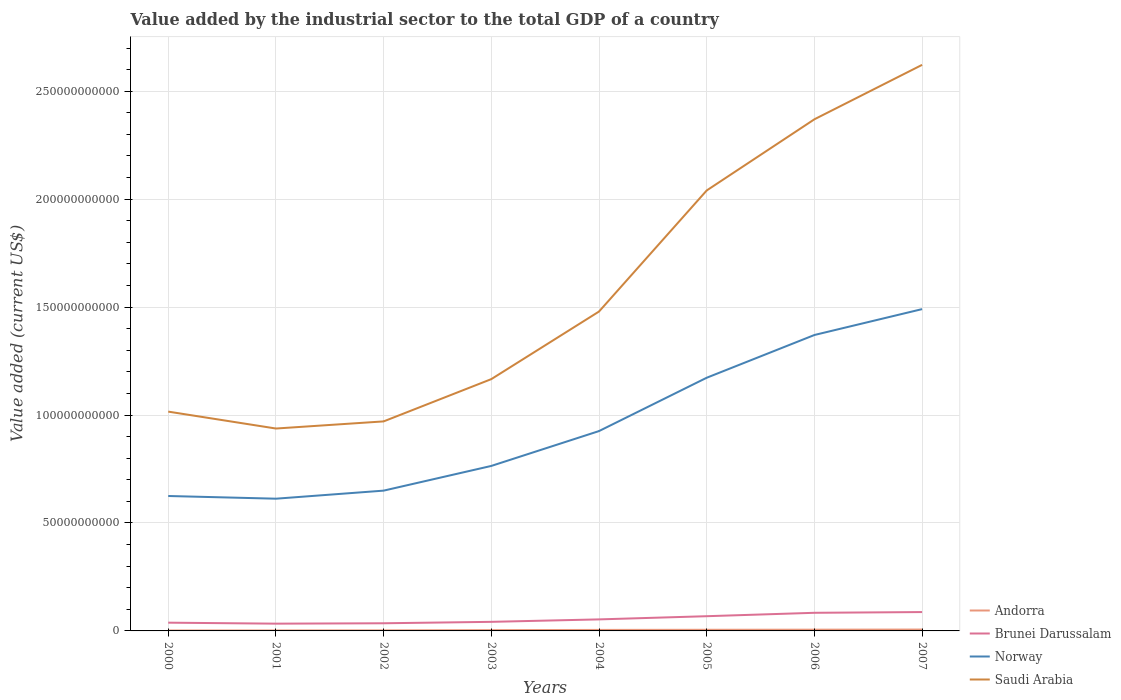How many different coloured lines are there?
Keep it short and to the point. 4. Is the number of lines equal to the number of legend labels?
Your answer should be compact. Yes. Across all years, what is the maximum value added by the industrial sector to the total GDP in Brunei Darussalam?
Your answer should be very brief. 3.36e+09. What is the total value added by the industrial sector to the total GDP in Norway in the graph?
Your response must be concise. -1.20e+1. What is the difference between the highest and the second highest value added by the industrial sector to the total GDP in Saudi Arabia?
Offer a very short reply. 1.68e+11. Is the value added by the industrial sector to the total GDP in Norway strictly greater than the value added by the industrial sector to the total GDP in Brunei Darussalam over the years?
Keep it short and to the point. No. How many lines are there?
Ensure brevity in your answer.  4. What is the difference between two consecutive major ticks on the Y-axis?
Offer a terse response. 5.00e+1. Where does the legend appear in the graph?
Provide a short and direct response. Bottom right. How many legend labels are there?
Ensure brevity in your answer.  4. How are the legend labels stacked?
Your response must be concise. Vertical. What is the title of the graph?
Make the answer very short. Value added by the industrial sector to the total GDP of a country. Does "United Kingdom" appear as one of the legend labels in the graph?
Ensure brevity in your answer.  No. What is the label or title of the X-axis?
Your response must be concise. Years. What is the label or title of the Y-axis?
Offer a terse response. Value added (current US$). What is the Value added (current US$) of Andorra in 2000?
Provide a succinct answer. 2.00e+08. What is the Value added (current US$) of Brunei Darussalam in 2000?
Your response must be concise. 3.82e+09. What is the Value added (current US$) in Norway in 2000?
Your answer should be very brief. 6.25e+1. What is the Value added (current US$) in Saudi Arabia in 2000?
Make the answer very short. 1.02e+11. What is the Value added (current US$) of Andorra in 2001?
Offer a terse response. 2.15e+08. What is the Value added (current US$) in Brunei Darussalam in 2001?
Your answer should be very brief. 3.36e+09. What is the Value added (current US$) of Norway in 2001?
Provide a succinct answer. 6.12e+1. What is the Value added (current US$) in Saudi Arabia in 2001?
Make the answer very short. 9.38e+1. What is the Value added (current US$) of Andorra in 2002?
Offer a very short reply. 2.56e+08. What is the Value added (current US$) of Brunei Darussalam in 2002?
Your answer should be compact. 3.54e+09. What is the Value added (current US$) of Norway in 2002?
Ensure brevity in your answer.  6.50e+1. What is the Value added (current US$) in Saudi Arabia in 2002?
Your answer should be compact. 9.71e+1. What is the Value added (current US$) in Andorra in 2003?
Offer a very short reply. 3.67e+08. What is the Value added (current US$) of Brunei Darussalam in 2003?
Provide a short and direct response. 4.21e+09. What is the Value added (current US$) of Norway in 2003?
Your answer should be compact. 7.64e+1. What is the Value added (current US$) of Saudi Arabia in 2003?
Ensure brevity in your answer.  1.17e+11. What is the Value added (current US$) in Andorra in 2004?
Make the answer very short. 4.62e+08. What is the Value added (current US$) in Brunei Darussalam in 2004?
Provide a short and direct response. 5.34e+09. What is the Value added (current US$) of Norway in 2004?
Give a very brief answer. 9.26e+1. What is the Value added (current US$) in Saudi Arabia in 2004?
Offer a terse response. 1.48e+11. What is the Value added (current US$) of Andorra in 2005?
Ensure brevity in your answer.  5.25e+08. What is the Value added (current US$) in Brunei Darussalam in 2005?
Your response must be concise. 6.82e+09. What is the Value added (current US$) of Norway in 2005?
Keep it short and to the point. 1.17e+11. What is the Value added (current US$) of Saudi Arabia in 2005?
Give a very brief answer. 2.04e+11. What is the Value added (current US$) of Andorra in 2006?
Provide a short and direct response. 5.82e+08. What is the Value added (current US$) of Brunei Darussalam in 2006?
Provide a short and direct response. 8.39e+09. What is the Value added (current US$) in Norway in 2006?
Make the answer very short. 1.37e+11. What is the Value added (current US$) of Saudi Arabia in 2006?
Provide a succinct answer. 2.37e+11. What is the Value added (current US$) of Andorra in 2007?
Offer a terse response. 6.37e+08. What is the Value added (current US$) in Brunei Darussalam in 2007?
Keep it short and to the point. 8.73e+09. What is the Value added (current US$) in Norway in 2007?
Make the answer very short. 1.49e+11. What is the Value added (current US$) in Saudi Arabia in 2007?
Make the answer very short. 2.62e+11. Across all years, what is the maximum Value added (current US$) in Andorra?
Your response must be concise. 6.37e+08. Across all years, what is the maximum Value added (current US$) in Brunei Darussalam?
Your response must be concise. 8.73e+09. Across all years, what is the maximum Value added (current US$) of Norway?
Provide a succinct answer. 1.49e+11. Across all years, what is the maximum Value added (current US$) of Saudi Arabia?
Your response must be concise. 2.62e+11. Across all years, what is the minimum Value added (current US$) of Andorra?
Make the answer very short. 2.00e+08. Across all years, what is the minimum Value added (current US$) of Brunei Darussalam?
Offer a very short reply. 3.36e+09. Across all years, what is the minimum Value added (current US$) in Norway?
Offer a terse response. 6.12e+1. Across all years, what is the minimum Value added (current US$) of Saudi Arabia?
Your answer should be compact. 9.38e+1. What is the total Value added (current US$) of Andorra in the graph?
Ensure brevity in your answer.  3.24e+09. What is the total Value added (current US$) in Brunei Darussalam in the graph?
Offer a very short reply. 4.42e+1. What is the total Value added (current US$) in Norway in the graph?
Offer a terse response. 7.61e+11. What is the total Value added (current US$) of Saudi Arabia in the graph?
Your answer should be very brief. 1.26e+12. What is the difference between the Value added (current US$) of Andorra in 2000 and that in 2001?
Give a very brief answer. -1.55e+07. What is the difference between the Value added (current US$) in Brunei Darussalam in 2000 and that in 2001?
Make the answer very short. 4.58e+08. What is the difference between the Value added (current US$) in Norway in 2000 and that in 2001?
Your answer should be very brief. 1.25e+09. What is the difference between the Value added (current US$) in Saudi Arabia in 2000 and that in 2001?
Your response must be concise. 7.83e+09. What is the difference between the Value added (current US$) in Andorra in 2000 and that in 2002?
Make the answer very short. -5.67e+07. What is the difference between the Value added (current US$) in Brunei Darussalam in 2000 and that in 2002?
Provide a short and direct response. 2.76e+08. What is the difference between the Value added (current US$) in Norway in 2000 and that in 2002?
Provide a succinct answer. -2.49e+09. What is the difference between the Value added (current US$) of Saudi Arabia in 2000 and that in 2002?
Make the answer very short. 4.53e+09. What is the difference between the Value added (current US$) of Andorra in 2000 and that in 2003?
Your response must be concise. -1.68e+08. What is the difference between the Value added (current US$) of Brunei Darussalam in 2000 and that in 2003?
Give a very brief answer. -3.85e+08. What is the difference between the Value added (current US$) in Norway in 2000 and that in 2003?
Make the answer very short. -1.39e+1. What is the difference between the Value added (current US$) of Saudi Arabia in 2000 and that in 2003?
Offer a terse response. -1.51e+1. What is the difference between the Value added (current US$) in Andorra in 2000 and that in 2004?
Keep it short and to the point. -2.62e+08. What is the difference between the Value added (current US$) in Brunei Darussalam in 2000 and that in 2004?
Provide a short and direct response. -1.52e+09. What is the difference between the Value added (current US$) in Norway in 2000 and that in 2004?
Your response must be concise. -3.01e+1. What is the difference between the Value added (current US$) of Saudi Arabia in 2000 and that in 2004?
Provide a short and direct response. -4.64e+1. What is the difference between the Value added (current US$) of Andorra in 2000 and that in 2005?
Your answer should be very brief. -3.25e+08. What is the difference between the Value added (current US$) of Brunei Darussalam in 2000 and that in 2005?
Your answer should be very brief. -3.00e+09. What is the difference between the Value added (current US$) in Norway in 2000 and that in 2005?
Ensure brevity in your answer.  -5.48e+1. What is the difference between the Value added (current US$) of Saudi Arabia in 2000 and that in 2005?
Give a very brief answer. -1.02e+11. What is the difference between the Value added (current US$) of Andorra in 2000 and that in 2006?
Offer a terse response. -3.82e+08. What is the difference between the Value added (current US$) in Brunei Darussalam in 2000 and that in 2006?
Your answer should be compact. -4.57e+09. What is the difference between the Value added (current US$) in Norway in 2000 and that in 2006?
Offer a terse response. -7.46e+1. What is the difference between the Value added (current US$) of Saudi Arabia in 2000 and that in 2006?
Make the answer very short. -1.35e+11. What is the difference between the Value added (current US$) in Andorra in 2000 and that in 2007?
Offer a terse response. -4.37e+08. What is the difference between the Value added (current US$) in Brunei Darussalam in 2000 and that in 2007?
Offer a terse response. -4.91e+09. What is the difference between the Value added (current US$) in Norway in 2000 and that in 2007?
Give a very brief answer. -8.66e+1. What is the difference between the Value added (current US$) of Saudi Arabia in 2000 and that in 2007?
Offer a very short reply. -1.61e+11. What is the difference between the Value added (current US$) of Andorra in 2001 and that in 2002?
Your answer should be compact. -4.12e+07. What is the difference between the Value added (current US$) in Brunei Darussalam in 2001 and that in 2002?
Make the answer very short. -1.82e+08. What is the difference between the Value added (current US$) of Norway in 2001 and that in 2002?
Make the answer very short. -3.73e+09. What is the difference between the Value added (current US$) of Saudi Arabia in 2001 and that in 2002?
Keep it short and to the point. -3.30e+09. What is the difference between the Value added (current US$) of Andorra in 2001 and that in 2003?
Keep it short and to the point. -1.52e+08. What is the difference between the Value added (current US$) of Brunei Darussalam in 2001 and that in 2003?
Give a very brief answer. -8.43e+08. What is the difference between the Value added (current US$) of Norway in 2001 and that in 2003?
Give a very brief answer. -1.52e+1. What is the difference between the Value added (current US$) in Saudi Arabia in 2001 and that in 2003?
Provide a short and direct response. -2.29e+1. What is the difference between the Value added (current US$) in Andorra in 2001 and that in 2004?
Offer a terse response. -2.47e+08. What is the difference between the Value added (current US$) in Brunei Darussalam in 2001 and that in 2004?
Your response must be concise. -1.98e+09. What is the difference between the Value added (current US$) of Norway in 2001 and that in 2004?
Provide a succinct answer. -3.13e+1. What is the difference between the Value added (current US$) in Saudi Arabia in 2001 and that in 2004?
Ensure brevity in your answer.  -5.42e+1. What is the difference between the Value added (current US$) of Andorra in 2001 and that in 2005?
Your response must be concise. -3.09e+08. What is the difference between the Value added (current US$) in Brunei Darussalam in 2001 and that in 2005?
Offer a very short reply. -3.46e+09. What is the difference between the Value added (current US$) in Norway in 2001 and that in 2005?
Offer a terse response. -5.60e+1. What is the difference between the Value added (current US$) in Saudi Arabia in 2001 and that in 2005?
Your answer should be very brief. -1.10e+11. What is the difference between the Value added (current US$) of Andorra in 2001 and that in 2006?
Make the answer very short. -3.67e+08. What is the difference between the Value added (current US$) in Brunei Darussalam in 2001 and that in 2006?
Keep it short and to the point. -5.03e+09. What is the difference between the Value added (current US$) in Norway in 2001 and that in 2006?
Ensure brevity in your answer.  -7.58e+1. What is the difference between the Value added (current US$) in Saudi Arabia in 2001 and that in 2006?
Your answer should be very brief. -1.43e+11. What is the difference between the Value added (current US$) of Andorra in 2001 and that in 2007?
Your answer should be very brief. -4.21e+08. What is the difference between the Value added (current US$) of Brunei Darussalam in 2001 and that in 2007?
Ensure brevity in your answer.  -5.37e+09. What is the difference between the Value added (current US$) in Norway in 2001 and that in 2007?
Make the answer very short. -8.78e+1. What is the difference between the Value added (current US$) of Saudi Arabia in 2001 and that in 2007?
Give a very brief answer. -1.68e+11. What is the difference between the Value added (current US$) in Andorra in 2002 and that in 2003?
Keep it short and to the point. -1.11e+08. What is the difference between the Value added (current US$) in Brunei Darussalam in 2002 and that in 2003?
Provide a short and direct response. -6.62e+08. What is the difference between the Value added (current US$) in Norway in 2002 and that in 2003?
Offer a very short reply. -1.14e+1. What is the difference between the Value added (current US$) of Saudi Arabia in 2002 and that in 2003?
Your response must be concise. -1.96e+1. What is the difference between the Value added (current US$) in Andorra in 2002 and that in 2004?
Provide a succinct answer. -2.06e+08. What is the difference between the Value added (current US$) in Brunei Darussalam in 2002 and that in 2004?
Offer a terse response. -1.80e+09. What is the difference between the Value added (current US$) of Norway in 2002 and that in 2004?
Make the answer very short. -2.76e+1. What is the difference between the Value added (current US$) in Saudi Arabia in 2002 and that in 2004?
Offer a terse response. -5.09e+1. What is the difference between the Value added (current US$) of Andorra in 2002 and that in 2005?
Your answer should be very brief. -2.68e+08. What is the difference between the Value added (current US$) of Brunei Darussalam in 2002 and that in 2005?
Make the answer very short. -3.28e+09. What is the difference between the Value added (current US$) in Norway in 2002 and that in 2005?
Give a very brief answer. -5.23e+1. What is the difference between the Value added (current US$) in Saudi Arabia in 2002 and that in 2005?
Provide a short and direct response. -1.07e+11. What is the difference between the Value added (current US$) of Andorra in 2002 and that in 2006?
Your response must be concise. -3.26e+08. What is the difference between the Value added (current US$) in Brunei Darussalam in 2002 and that in 2006?
Your answer should be compact. -4.85e+09. What is the difference between the Value added (current US$) of Norway in 2002 and that in 2006?
Make the answer very short. -7.21e+1. What is the difference between the Value added (current US$) in Saudi Arabia in 2002 and that in 2006?
Make the answer very short. -1.40e+11. What is the difference between the Value added (current US$) of Andorra in 2002 and that in 2007?
Make the answer very short. -3.80e+08. What is the difference between the Value added (current US$) in Brunei Darussalam in 2002 and that in 2007?
Your answer should be very brief. -5.19e+09. What is the difference between the Value added (current US$) of Norway in 2002 and that in 2007?
Keep it short and to the point. -8.41e+1. What is the difference between the Value added (current US$) in Saudi Arabia in 2002 and that in 2007?
Ensure brevity in your answer.  -1.65e+11. What is the difference between the Value added (current US$) in Andorra in 2003 and that in 2004?
Your answer should be very brief. -9.47e+07. What is the difference between the Value added (current US$) of Brunei Darussalam in 2003 and that in 2004?
Make the answer very short. -1.14e+09. What is the difference between the Value added (current US$) in Norway in 2003 and that in 2004?
Your response must be concise. -1.61e+1. What is the difference between the Value added (current US$) of Saudi Arabia in 2003 and that in 2004?
Your answer should be very brief. -3.13e+1. What is the difference between the Value added (current US$) in Andorra in 2003 and that in 2005?
Your answer should be compact. -1.57e+08. What is the difference between the Value added (current US$) of Brunei Darussalam in 2003 and that in 2005?
Your answer should be very brief. -2.61e+09. What is the difference between the Value added (current US$) of Norway in 2003 and that in 2005?
Offer a very short reply. -4.08e+1. What is the difference between the Value added (current US$) of Saudi Arabia in 2003 and that in 2005?
Offer a terse response. -8.74e+1. What is the difference between the Value added (current US$) in Andorra in 2003 and that in 2006?
Your answer should be compact. -2.15e+08. What is the difference between the Value added (current US$) in Brunei Darussalam in 2003 and that in 2006?
Your answer should be very brief. -4.19e+09. What is the difference between the Value added (current US$) of Norway in 2003 and that in 2006?
Keep it short and to the point. -6.06e+1. What is the difference between the Value added (current US$) in Saudi Arabia in 2003 and that in 2006?
Your response must be concise. -1.20e+11. What is the difference between the Value added (current US$) in Andorra in 2003 and that in 2007?
Ensure brevity in your answer.  -2.69e+08. What is the difference between the Value added (current US$) of Brunei Darussalam in 2003 and that in 2007?
Keep it short and to the point. -4.53e+09. What is the difference between the Value added (current US$) of Norway in 2003 and that in 2007?
Offer a terse response. -7.26e+1. What is the difference between the Value added (current US$) in Saudi Arabia in 2003 and that in 2007?
Make the answer very short. -1.46e+11. What is the difference between the Value added (current US$) in Andorra in 2004 and that in 2005?
Keep it short and to the point. -6.25e+07. What is the difference between the Value added (current US$) of Brunei Darussalam in 2004 and that in 2005?
Offer a terse response. -1.48e+09. What is the difference between the Value added (current US$) of Norway in 2004 and that in 2005?
Provide a succinct answer. -2.47e+1. What is the difference between the Value added (current US$) of Saudi Arabia in 2004 and that in 2005?
Your response must be concise. -5.61e+1. What is the difference between the Value added (current US$) of Andorra in 2004 and that in 2006?
Give a very brief answer. -1.20e+08. What is the difference between the Value added (current US$) in Brunei Darussalam in 2004 and that in 2006?
Give a very brief answer. -3.05e+09. What is the difference between the Value added (current US$) of Norway in 2004 and that in 2006?
Provide a short and direct response. -4.45e+1. What is the difference between the Value added (current US$) in Saudi Arabia in 2004 and that in 2006?
Your answer should be very brief. -8.90e+1. What is the difference between the Value added (current US$) in Andorra in 2004 and that in 2007?
Ensure brevity in your answer.  -1.74e+08. What is the difference between the Value added (current US$) of Brunei Darussalam in 2004 and that in 2007?
Provide a short and direct response. -3.39e+09. What is the difference between the Value added (current US$) of Norway in 2004 and that in 2007?
Your answer should be compact. -5.65e+1. What is the difference between the Value added (current US$) of Saudi Arabia in 2004 and that in 2007?
Provide a succinct answer. -1.14e+11. What is the difference between the Value added (current US$) in Andorra in 2005 and that in 2006?
Offer a very short reply. -5.73e+07. What is the difference between the Value added (current US$) in Brunei Darussalam in 2005 and that in 2006?
Make the answer very short. -1.57e+09. What is the difference between the Value added (current US$) in Norway in 2005 and that in 2006?
Offer a terse response. -1.98e+1. What is the difference between the Value added (current US$) in Saudi Arabia in 2005 and that in 2006?
Keep it short and to the point. -3.30e+1. What is the difference between the Value added (current US$) of Andorra in 2005 and that in 2007?
Offer a terse response. -1.12e+08. What is the difference between the Value added (current US$) in Brunei Darussalam in 2005 and that in 2007?
Provide a short and direct response. -1.91e+09. What is the difference between the Value added (current US$) in Norway in 2005 and that in 2007?
Provide a succinct answer. -3.18e+1. What is the difference between the Value added (current US$) of Saudi Arabia in 2005 and that in 2007?
Your answer should be very brief. -5.82e+1. What is the difference between the Value added (current US$) in Andorra in 2006 and that in 2007?
Provide a short and direct response. -5.46e+07. What is the difference between the Value added (current US$) of Brunei Darussalam in 2006 and that in 2007?
Offer a terse response. -3.39e+08. What is the difference between the Value added (current US$) of Norway in 2006 and that in 2007?
Your answer should be very brief. -1.20e+1. What is the difference between the Value added (current US$) in Saudi Arabia in 2006 and that in 2007?
Provide a succinct answer. -2.52e+1. What is the difference between the Value added (current US$) of Andorra in 2000 and the Value added (current US$) of Brunei Darussalam in 2001?
Your answer should be compact. -3.16e+09. What is the difference between the Value added (current US$) of Andorra in 2000 and the Value added (current US$) of Norway in 2001?
Your response must be concise. -6.10e+1. What is the difference between the Value added (current US$) in Andorra in 2000 and the Value added (current US$) in Saudi Arabia in 2001?
Offer a very short reply. -9.36e+1. What is the difference between the Value added (current US$) in Brunei Darussalam in 2000 and the Value added (current US$) in Norway in 2001?
Offer a terse response. -5.74e+1. What is the difference between the Value added (current US$) in Brunei Darussalam in 2000 and the Value added (current US$) in Saudi Arabia in 2001?
Give a very brief answer. -8.99e+1. What is the difference between the Value added (current US$) in Norway in 2000 and the Value added (current US$) in Saudi Arabia in 2001?
Make the answer very short. -3.13e+1. What is the difference between the Value added (current US$) of Andorra in 2000 and the Value added (current US$) of Brunei Darussalam in 2002?
Your answer should be compact. -3.34e+09. What is the difference between the Value added (current US$) in Andorra in 2000 and the Value added (current US$) in Norway in 2002?
Make the answer very short. -6.48e+1. What is the difference between the Value added (current US$) of Andorra in 2000 and the Value added (current US$) of Saudi Arabia in 2002?
Give a very brief answer. -9.69e+1. What is the difference between the Value added (current US$) of Brunei Darussalam in 2000 and the Value added (current US$) of Norway in 2002?
Your answer should be compact. -6.12e+1. What is the difference between the Value added (current US$) of Brunei Darussalam in 2000 and the Value added (current US$) of Saudi Arabia in 2002?
Offer a very short reply. -9.32e+1. What is the difference between the Value added (current US$) of Norway in 2000 and the Value added (current US$) of Saudi Arabia in 2002?
Keep it short and to the point. -3.46e+1. What is the difference between the Value added (current US$) of Andorra in 2000 and the Value added (current US$) of Brunei Darussalam in 2003?
Make the answer very short. -4.01e+09. What is the difference between the Value added (current US$) of Andorra in 2000 and the Value added (current US$) of Norway in 2003?
Your response must be concise. -7.62e+1. What is the difference between the Value added (current US$) of Andorra in 2000 and the Value added (current US$) of Saudi Arabia in 2003?
Make the answer very short. -1.16e+11. What is the difference between the Value added (current US$) in Brunei Darussalam in 2000 and the Value added (current US$) in Norway in 2003?
Your response must be concise. -7.26e+1. What is the difference between the Value added (current US$) of Brunei Darussalam in 2000 and the Value added (current US$) of Saudi Arabia in 2003?
Make the answer very short. -1.13e+11. What is the difference between the Value added (current US$) of Norway in 2000 and the Value added (current US$) of Saudi Arabia in 2003?
Provide a succinct answer. -5.41e+1. What is the difference between the Value added (current US$) in Andorra in 2000 and the Value added (current US$) in Brunei Darussalam in 2004?
Offer a terse response. -5.14e+09. What is the difference between the Value added (current US$) of Andorra in 2000 and the Value added (current US$) of Norway in 2004?
Your response must be concise. -9.24e+1. What is the difference between the Value added (current US$) of Andorra in 2000 and the Value added (current US$) of Saudi Arabia in 2004?
Make the answer very short. -1.48e+11. What is the difference between the Value added (current US$) of Brunei Darussalam in 2000 and the Value added (current US$) of Norway in 2004?
Offer a very short reply. -8.87e+1. What is the difference between the Value added (current US$) of Brunei Darussalam in 2000 and the Value added (current US$) of Saudi Arabia in 2004?
Provide a succinct answer. -1.44e+11. What is the difference between the Value added (current US$) of Norway in 2000 and the Value added (current US$) of Saudi Arabia in 2004?
Provide a succinct answer. -8.54e+1. What is the difference between the Value added (current US$) of Andorra in 2000 and the Value added (current US$) of Brunei Darussalam in 2005?
Make the answer very short. -6.62e+09. What is the difference between the Value added (current US$) of Andorra in 2000 and the Value added (current US$) of Norway in 2005?
Make the answer very short. -1.17e+11. What is the difference between the Value added (current US$) in Andorra in 2000 and the Value added (current US$) in Saudi Arabia in 2005?
Your answer should be compact. -2.04e+11. What is the difference between the Value added (current US$) of Brunei Darussalam in 2000 and the Value added (current US$) of Norway in 2005?
Provide a short and direct response. -1.13e+11. What is the difference between the Value added (current US$) in Brunei Darussalam in 2000 and the Value added (current US$) in Saudi Arabia in 2005?
Your answer should be very brief. -2.00e+11. What is the difference between the Value added (current US$) in Norway in 2000 and the Value added (current US$) in Saudi Arabia in 2005?
Offer a terse response. -1.42e+11. What is the difference between the Value added (current US$) of Andorra in 2000 and the Value added (current US$) of Brunei Darussalam in 2006?
Provide a short and direct response. -8.19e+09. What is the difference between the Value added (current US$) of Andorra in 2000 and the Value added (current US$) of Norway in 2006?
Give a very brief answer. -1.37e+11. What is the difference between the Value added (current US$) of Andorra in 2000 and the Value added (current US$) of Saudi Arabia in 2006?
Your answer should be compact. -2.37e+11. What is the difference between the Value added (current US$) of Brunei Darussalam in 2000 and the Value added (current US$) of Norway in 2006?
Your answer should be compact. -1.33e+11. What is the difference between the Value added (current US$) in Brunei Darussalam in 2000 and the Value added (current US$) in Saudi Arabia in 2006?
Give a very brief answer. -2.33e+11. What is the difference between the Value added (current US$) of Norway in 2000 and the Value added (current US$) of Saudi Arabia in 2006?
Provide a short and direct response. -1.74e+11. What is the difference between the Value added (current US$) in Andorra in 2000 and the Value added (current US$) in Brunei Darussalam in 2007?
Offer a very short reply. -8.53e+09. What is the difference between the Value added (current US$) of Andorra in 2000 and the Value added (current US$) of Norway in 2007?
Ensure brevity in your answer.  -1.49e+11. What is the difference between the Value added (current US$) of Andorra in 2000 and the Value added (current US$) of Saudi Arabia in 2007?
Make the answer very short. -2.62e+11. What is the difference between the Value added (current US$) of Brunei Darussalam in 2000 and the Value added (current US$) of Norway in 2007?
Your answer should be very brief. -1.45e+11. What is the difference between the Value added (current US$) in Brunei Darussalam in 2000 and the Value added (current US$) in Saudi Arabia in 2007?
Provide a short and direct response. -2.58e+11. What is the difference between the Value added (current US$) of Norway in 2000 and the Value added (current US$) of Saudi Arabia in 2007?
Provide a succinct answer. -2.00e+11. What is the difference between the Value added (current US$) in Andorra in 2001 and the Value added (current US$) in Brunei Darussalam in 2002?
Ensure brevity in your answer.  -3.33e+09. What is the difference between the Value added (current US$) of Andorra in 2001 and the Value added (current US$) of Norway in 2002?
Your answer should be very brief. -6.48e+1. What is the difference between the Value added (current US$) in Andorra in 2001 and the Value added (current US$) in Saudi Arabia in 2002?
Your answer should be compact. -9.68e+1. What is the difference between the Value added (current US$) of Brunei Darussalam in 2001 and the Value added (current US$) of Norway in 2002?
Offer a terse response. -6.16e+1. What is the difference between the Value added (current US$) in Brunei Darussalam in 2001 and the Value added (current US$) in Saudi Arabia in 2002?
Make the answer very short. -9.37e+1. What is the difference between the Value added (current US$) of Norway in 2001 and the Value added (current US$) of Saudi Arabia in 2002?
Provide a short and direct response. -3.58e+1. What is the difference between the Value added (current US$) of Andorra in 2001 and the Value added (current US$) of Brunei Darussalam in 2003?
Offer a terse response. -3.99e+09. What is the difference between the Value added (current US$) of Andorra in 2001 and the Value added (current US$) of Norway in 2003?
Ensure brevity in your answer.  -7.62e+1. What is the difference between the Value added (current US$) of Andorra in 2001 and the Value added (current US$) of Saudi Arabia in 2003?
Offer a very short reply. -1.16e+11. What is the difference between the Value added (current US$) of Brunei Darussalam in 2001 and the Value added (current US$) of Norway in 2003?
Your answer should be compact. -7.31e+1. What is the difference between the Value added (current US$) of Brunei Darussalam in 2001 and the Value added (current US$) of Saudi Arabia in 2003?
Provide a succinct answer. -1.13e+11. What is the difference between the Value added (current US$) in Norway in 2001 and the Value added (current US$) in Saudi Arabia in 2003?
Provide a succinct answer. -5.54e+1. What is the difference between the Value added (current US$) in Andorra in 2001 and the Value added (current US$) in Brunei Darussalam in 2004?
Provide a succinct answer. -5.13e+09. What is the difference between the Value added (current US$) of Andorra in 2001 and the Value added (current US$) of Norway in 2004?
Offer a very short reply. -9.24e+1. What is the difference between the Value added (current US$) of Andorra in 2001 and the Value added (current US$) of Saudi Arabia in 2004?
Offer a terse response. -1.48e+11. What is the difference between the Value added (current US$) of Brunei Darussalam in 2001 and the Value added (current US$) of Norway in 2004?
Give a very brief answer. -8.92e+1. What is the difference between the Value added (current US$) in Brunei Darussalam in 2001 and the Value added (current US$) in Saudi Arabia in 2004?
Make the answer very short. -1.45e+11. What is the difference between the Value added (current US$) in Norway in 2001 and the Value added (current US$) in Saudi Arabia in 2004?
Provide a short and direct response. -8.67e+1. What is the difference between the Value added (current US$) in Andorra in 2001 and the Value added (current US$) in Brunei Darussalam in 2005?
Give a very brief answer. -6.61e+09. What is the difference between the Value added (current US$) in Andorra in 2001 and the Value added (current US$) in Norway in 2005?
Provide a succinct answer. -1.17e+11. What is the difference between the Value added (current US$) of Andorra in 2001 and the Value added (current US$) of Saudi Arabia in 2005?
Your response must be concise. -2.04e+11. What is the difference between the Value added (current US$) in Brunei Darussalam in 2001 and the Value added (current US$) in Norway in 2005?
Your response must be concise. -1.14e+11. What is the difference between the Value added (current US$) in Brunei Darussalam in 2001 and the Value added (current US$) in Saudi Arabia in 2005?
Your answer should be very brief. -2.01e+11. What is the difference between the Value added (current US$) of Norway in 2001 and the Value added (current US$) of Saudi Arabia in 2005?
Your response must be concise. -1.43e+11. What is the difference between the Value added (current US$) in Andorra in 2001 and the Value added (current US$) in Brunei Darussalam in 2006?
Offer a terse response. -8.18e+09. What is the difference between the Value added (current US$) of Andorra in 2001 and the Value added (current US$) of Norway in 2006?
Your response must be concise. -1.37e+11. What is the difference between the Value added (current US$) in Andorra in 2001 and the Value added (current US$) in Saudi Arabia in 2006?
Keep it short and to the point. -2.37e+11. What is the difference between the Value added (current US$) of Brunei Darussalam in 2001 and the Value added (current US$) of Norway in 2006?
Make the answer very short. -1.34e+11. What is the difference between the Value added (current US$) of Brunei Darussalam in 2001 and the Value added (current US$) of Saudi Arabia in 2006?
Provide a short and direct response. -2.34e+11. What is the difference between the Value added (current US$) of Norway in 2001 and the Value added (current US$) of Saudi Arabia in 2006?
Ensure brevity in your answer.  -1.76e+11. What is the difference between the Value added (current US$) of Andorra in 2001 and the Value added (current US$) of Brunei Darussalam in 2007?
Keep it short and to the point. -8.52e+09. What is the difference between the Value added (current US$) of Andorra in 2001 and the Value added (current US$) of Norway in 2007?
Ensure brevity in your answer.  -1.49e+11. What is the difference between the Value added (current US$) of Andorra in 2001 and the Value added (current US$) of Saudi Arabia in 2007?
Provide a short and direct response. -2.62e+11. What is the difference between the Value added (current US$) in Brunei Darussalam in 2001 and the Value added (current US$) in Norway in 2007?
Your answer should be very brief. -1.46e+11. What is the difference between the Value added (current US$) in Brunei Darussalam in 2001 and the Value added (current US$) in Saudi Arabia in 2007?
Offer a very short reply. -2.59e+11. What is the difference between the Value added (current US$) of Norway in 2001 and the Value added (current US$) of Saudi Arabia in 2007?
Offer a very short reply. -2.01e+11. What is the difference between the Value added (current US$) of Andorra in 2002 and the Value added (current US$) of Brunei Darussalam in 2003?
Offer a terse response. -3.95e+09. What is the difference between the Value added (current US$) of Andorra in 2002 and the Value added (current US$) of Norway in 2003?
Make the answer very short. -7.62e+1. What is the difference between the Value added (current US$) of Andorra in 2002 and the Value added (current US$) of Saudi Arabia in 2003?
Provide a succinct answer. -1.16e+11. What is the difference between the Value added (current US$) of Brunei Darussalam in 2002 and the Value added (current US$) of Norway in 2003?
Offer a very short reply. -7.29e+1. What is the difference between the Value added (current US$) of Brunei Darussalam in 2002 and the Value added (current US$) of Saudi Arabia in 2003?
Make the answer very short. -1.13e+11. What is the difference between the Value added (current US$) in Norway in 2002 and the Value added (current US$) in Saudi Arabia in 2003?
Keep it short and to the point. -5.17e+1. What is the difference between the Value added (current US$) in Andorra in 2002 and the Value added (current US$) in Brunei Darussalam in 2004?
Your answer should be very brief. -5.09e+09. What is the difference between the Value added (current US$) of Andorra in 2002 and the Value added (current US$) of Norway in 2004?
Provide a short and direct response. -9.23e+1. What is the difference between the Value added (current US$) in Andorra in 2002 and the Value added (current US$) in Saudi Arabia in 2004?
Give a very brief answer. -1.48e+11. What is the difference between the Value added (current US$) of Brunei Darussalam in 2002 and the Value added (current US$) of Norway in 2004?
Provide a succinct answer. -8.90e+1. What is the difference between the Value added (current US$) in Brunei Darussalam in 2002 and the Value added (current US$) in Saudi Arabia in 2004?
Make the answer very short. -1.44e+11. What is the difference between the Value added (current US$) of Norway in 2002 and the Value added (current US$) of Saudi Arabia in 2004?
Make the answer very short. -8.30e+1. What is the difference between the Value added (current US$) in Andorra in 2002 and the Value added (current US$) in Brunei Darussalam in 2005?
Offer a terse response. -6.56e+09. What is the difference between the Value added (current US$) of Andorra in 2002 and the Value added (current US$) of Norway in 2005?
Your response must be concise. -1.17e+11. What is the difference between the Value added (current US$) of Andorra in 2002 and the Value added (current US$) of Saudi Arabia in 2005?
Your answer should be very brief. -2.04e+11. What is the difference between the Value added (current US$) in Brunei Darussalam in 2002 and the Value added (current US$) in Norway in 2005?
Ensure brevity in your answer.  -1.14e+11. What is the difference between the Value added (current US$) in Brunei Darussalam in 2002 and the Value added (current US$) in Saudi Arabia in 2005?
Your response must be concise. -2.00e+11. What is the difference between the Value added (current US$) of Norway in 2002 and the Value added (current US$) of Saudi Arabia in 2005?
Make the answer very short. -1.39e+11. What is the difference between the Value added (current US$) of Andorra in 2002 and the Value added (current US$) of Brunei Darussalam in 2006?
Ensure brevity in your answer.  -8.14e+09. What is the difference between the Value added (current US$) of Andorra in 2002 and the Value added (current US$) of Norway in 2006?
Provide a succinct answer. -1.37e+11. What is the difference between the Value added (current US$) in Andorra in 2002 and the Value added (current US$) in Saudi Arabia in 2006?
Provide a short and direct response. -2.37e+11. What is the difference between the Value added (current US$) of Brunei Darussalam in 2002 and the Value added (current US$) of Norway in 2006?
Make the answer very short. -1.34e+11. What is the difference between the Value added (current US$) of Brunei Darussalam in 2002 and the Value added (current US$) of Saudi Arabia in 2006?
Provide a succinct answer. -2.33e+11. What is the difference between the Value added (current US$) of Norway in 2002 and the Value added (current US$) of Saudi Arabia in 2006?
Give a very brief answer. -1.72e+11. What is the difference between the Value added (current US$) in Andorra in 2002 and the Value added (current US$) in Brunei Darussalam in 2007?
Make the answer very short. -8.48e+09. What is the difference between the Value added (current US$) in Andorra in 2002 and the Value added (current US$) in Norway in 2007?
Your response must be concise. -1.49e+11. What is the difference between the Value added (current US$) of Andorra in 2002 and the Value added (current US$) of Saudi Arabia in 2007?
Provide a short and direct response. -2.62e+11. What is the difference between the Value added (current US$) in Brunei Darussalam in 2002 and the Value added (current US$) in Norway in 2007?
Keep it short and to the point. -1.46e+11. What is the difference between the Value added (current US$) of Brunei Darussalam in 2002 and the Value added (current US$) of Saudi Arabia in 2007?
Your answer should be compact. -2.59e+11. What is the difference between the Value added (current US$) of Norway in 2002 and the Value added (current US$) of Saudi Arabia in 2007?
Make the answer very short. -1.97e+11. What is the difference between the Value added (current US$) in Andorra in 2003 and the Value added (current US$) in Brunei Darussalam in 2004?
Offer a terse response. -4.97e+09. What is the difference between the Value added (current US$) in Andorra in 2003 and the Value added (current US$) in Norway in 2004?
Ensure brevity in your answer.  -9.22e+1. What is the difference between the Value added (current US$) of Andorra in 2003 and the Value added (current US$) of Saudi Arabia in 2004?
Your answer should be very brief. -1.48e+11. What is the difference between the Value added (current US$) of Brunei Darussalam in 2003 and the Value added (current US$) of Norway in 2004?
Offer a very short reply. -8.84e+1. What is the difference between the Value added (current US$) in Brunei Darussalam in 2003 and the Value added (current US$) in Saudi Arabia in 2004?
Make the answer very short. -1.44e+11. What is the difference between the Value added (current US$) of Norway in 2003 and the Value added (current US$) of Saudi Arabia in 2004?
Keep it short and to the point. -7.15e+1. What is the difference between the Value added (current US$) of Andorra in 2003 and the Value added (current US$) of Brunei Darussalam in 2005?
Your response must be concise. -6.45e+09. What is the difference between the Value added (current US$) in Andorra in 2003 and the Value added (current US$) in Norway in 2005?
Ensure brevity in your answer.  -1.17e+11. What is the difference between the Value added (current US$) in Andorra in 2003 and the Value added (current US$) in Saudi Arabia in 2005?
Offer a very short reply. -2.04e+11. What is the difference between the Value added (current US$) of Brunei Darussalam in 2003 and the Value added (current US$) of Norway in 2005?
Ensure brevity in your answer.  -1.13e+11. What is the difference between the Value added (current US$) of Brunei Darussalam in 2003 and the Value added (current US$) of Saudi Arabia in 2005?
Give a very brief answer. -2.00e+11. What is the difference between the Value added (current US$) in Norway in 2003 and the Value added (current US$) in Saudi Arabia in 2005?
Make the answer very short. -1.28e+11. What is the difference between the Value added (current US$) of Andorra in 2003 and the Value added (current US$) of Brunei Darussalam in 2006?
Provide a short and direct response. -8.03e+09. What is the difference between the Value added (current US$) of Andorra in 2003 and the Value added (current US$) of Norway in 2006?
Give a very brief answer. -1.37e+11. What is the difference between the Value added (current US$) of Andorra in 2003 and the Value added (current US$) of Saudi Arabia in 2006?
Give a very brief answer. -2.37e+11. What is the difference between the Value added (current US$) in Brunei Darussalam in 2003 and the Value added (current US$) in Norway in 2006?
Make the answer very short. -1.33e+11. What is the difference between the Value added (current US$) of Brunei Darussalam in 2003 and the Value added (current US$) of Saudi Arabia in 2006?
Give a very brief answer. -2.33e+11. What is the difference between the Value added (current US$) in Norway in 2003 and the Value added (current US$) in Saudi Arabia in 2006?
Your response must be concise. -1.61e+11. What is the difference between the Value added (current US$) of Andorra in 2003 and the Value added (current US$) of Brunei Darussalam in 2007?
Make the answer very short. -8.37e+09. What is the difference between the Value added (current US$) in Andorra in 2003 and the Value added (current US$) in Norway in 2007?
Provide a succinct answer. -1.49e+11. What is the difference between the Value added (current US$) of Andorra in 2003 and the Value added (current US$) of Saudi Arabia in 2007?
Give a very brief answer. -2.62e+11. What is the difference between the Value added (current US$) of Brunei Darussalam in 2003 and the Value added (current US$) of Norway in 2007?
Offer a very short reply. -1.45e+11. What is the difference between the Value added (current US$) of Brunei Darussalam in 2003 and the Value added (current US$) of Saudi Arabia in 2007?
Give a very brief answer. -2.58e+11. What is the difference between the Value added (current US$) in Norway in 2003 and the Value added (current US$) in Saudi Arabia in 2007?
Make the answer very short. -1.86e+11. What is the difference between the Value added (current US$) in Andorra in 2004 and the Value added (current US$) in Brunei Darussalam in 2005?
Give a very brief answer. -6.36e+09. What is the difference between the Value added (current US$) of Andorra in 2004 and the Value added (current US$) of Norway in 2005?
Offer a very short reply. -1.17e+11. What is the difference between the Value added (current US$) in Andorra in 2004 and the Value added (current US$) in Saudi Arabia in 2005?
Offer a very short reply. -2.04e+11. What is the difference between the Value added (current US$) in Brunei Darussalam in 2004 and the Value added (current US$) in Norway in 2005?
Ensure brevity in your answer.  -1.12e+11. What is the difference between the Value added (current US$) of Brunei Darussalam in 2004 and the Value added (current US$) of Saudi Arabia in 2005?
Provide a short and direct response. -1.99e+11. What is the difference between the Value added (current US$) in Norway in 2004 and the Value added (current US$) in Saudi Arabia in 2005?
Give a very brief answer. -1.11e+11. What is the difference between the Value added (current US$) of Andorra in 2004 and the Value added (current US$) of Brunei Darussalam in 2006?
Give a very brief answer. -7.93e+09. What is the difference between the Value added (current US$) in Andorra in 2004 and the Value added (current US$) in Norway in 2006?
Offer a very short reply. -1.37e+11. What is the difference between the Value added (current US$) of Andorra in 2004 and the Value added (current US$) of Saudi Arabia in 2006?
Ensure brevity in your answer.  -2.37e+11. What is the difference between the Value added (current US$) in Brunei Darussalam in 2004 and the Value added (current US$) in Norway in 2006?
Ensure brevity in your answer.  -1.32e+11. What is the difference between the Value added (current US$) in Brunei Darussalam in 2004 and the Value added (current US$) in Saudi Arabia in 2006?
Your answer should be very brief. -2.32e+11. What is the difference between the Value added (current US$) in Norway in 2004 and the Value added (current US$) in Saudi Arabia in 2006?
Your response must be concise. -1.44e+11. What is the difference between the Value added (current US$) of Andorra in 2004 and the Value added (current US$) of Brunei Darussalam in 2007?
Keep it short and to the point. -8.27e+09. What is the difference between the Value added (current US$) in Andorra in 2004 and the Value added (current US$) in Norway in 2007?
Provide a succinct answer. -1.49e+11. What is the difference between the Value added (current US$) in Andorra in 2004 and the Value added (current US$) in Saudi Arabia in 2007?
Provide a succinct answer. -2.62e+11. What is the difference between the Value added (current US$) in Brunei Darussalam in 2004 and the Value added (current US$) in Norway in 2007?
Your answer should be compact. -1.44e+11. What is the difference between the Value added (current US$) in Brunei Darussalam in 2004 and the Value added (current US$) in Saudi Arabia in 2007?
Make the answer very short. -2.57e+11. What is the difference between the Value added (current US$) of Norway in 2004 and the Value added (current US$) of Saudi Arabia in 2007?
Keep it short and to the point. -1.70e+11. What is the difference between the Value added (current US$) of Andorra in 2005 and the Value added (current US$) of Brunei Darussalam in 2006?
Make the answer very short. -7.87e+09. What is the difference between the Value added (current US$) of Andorra in 2005 and the Value added (current US$) of Norway in 2006?
Offer a very short reply. -1.37e+11. What is the difference between the Value added (current US$) in Andorra in 2005 and the Value added (current US$) in Saudi Arabia in 2006?
Provide a short and direct response. -2.36e+11. What is the difference between the Value added (current US$) in Brunei Darussalam in 2005 and the Value added (current US$) in Norway in 2006?
Provide a succinct answer. -1.30e+11. What is the difference between the Value added (current US$) of Brunei Darussalam in 2005 and the Value added (current US$) of Saudi Arabia in 2006?
Ensure brevity in your answer.  -2.30e+11. What is the difference between the Value added (current US$) in Norway in 2005 and the Value added (current US$) in Saudi Arabia in 2006?
Keep it short and to the point. -1.20e+11. What is the difference between the Value added (current US$) of Andorra in 2005 and the Value added (current US$) of Brunei Darussalam in 2007?
Make the answer very short. -8.21e+09. What is the difference between the Value added (current US$) in Andorra in 2005 and the Value added (current US$) in Norway in 2007?
Make the answer very short. -1.49e+11. What is the difference between the Value added (current US$) in Andorra in 2005 and the Value added (current US$) in Saudi Arabia in 2007?
Make the answer very short. -2.62e+11. What is the difference between the Value added (current US$) of Brunei Darussalam in 2005 and the Value added (current US$) of Norway in 2007?
Your answer should be compact. -1.42e+11. What is the difference between the Value added (current US$) in Brunei Darussalam in 2005 and the Value added (current US$) in Saudi Arabia in 2007?
Keep it short and to the point. -2.55e+11. What is the difference between the Value added (current US$) of Norway in 2005 and the Value added (current US$) of Saudi Arabia in 2007?
Your response must be concise. -1.45e+11. What is the difference between the Value added (current US$) in Andorra in 2006 and the Value added (current US$) in Brunei Darussalam in 2007?
Provide a succinct answer. -8.15e+09. What is the difference between the Value added (current US$) in Andorra in 2006 and the Value added (current US$) in Norway in 2007?
Provide a short and direct response. -1.48e+11. What is the difference between the Value added (current US$) of Andorra in 2006 and the Value added (current US$) of Saudi Arabia in 2007?
Give a very brief answer. -2.62e+11. What is the difference between the Value added (current US$) in Brunei Darussalam in 2006 and the Value added (current US$) in Norway in 2007?
Your answer should be very brief. -1.41e+11. What is the difference between the Value added (current US$) of Brunei Darussalam in 2006 and the Value added (current US$) of Saudi Arabia in 2007?
Ensure brevity in your answer.  -2.54e+11. What is the difference between the Value added (current US$) in Norway in 2006 and the Value added (current US$) in Saudi Arabia in 2007?
Your answer should be compact. -1.25e+11. What is the average Value added (current US$) in Andorra per year?
Your answer should be very brief. 4.06e+08. What is the average Value added (current US$) in Brunei Darussalam per year?
Your answer should be compact. 5.53e+09. What is the average Value added (current US$) of Norway per year?
Provide a succinct answer. 9.51e+1. What is the average Value added (current US$) in Saudi Arabia per year?
Offer a very short reply. 1.58e+11. In the year 2000, what is the difference between the Value added (current US$) of Andorra and Value added (current US$) of Brunei Darussalam?
Offer a terse response. -3.62e+09. In the year 2000, what is the difference between the Value added (current US$) in Andorra and Value added (current US$) in Norway?
Give a very brief answer. -6.23e+1. In the year 2000, what is the difference between the Value added (current US$) in Andorra and Value added (current US$) in Saudi Arabia?
Your answer should be very brief. -1.01e+11. In the year 2000, what is the difference between the Value added (current US$) in Brunei Darussalam and Value added (current US$) in Norway?
Your response must be concise. -5.87e+1. In the year 2000, what is the difference between the Value added (current US$) of Brunei Darussalam and Value added (current US$) of Saudi Arabia?
Your response must be concise. -9.78e+1. In the year 2000, what is the difference between the Value added (current US$) of Norway and Value added (current US$) of Saudi Arabia?
Give a very brief answer. -3.91e+1. In the year 2001, what is the difference between the Value added (current US$) of Andorra and Value added (current US$) of Brunei Darussalam?
Ensure brevity in your answer.  -3.15e+09. In the year 2001, what is the difference between the Value added (current US$) of Andorra and Value added (current US$) of Norway?
Your answer should be very brief. -6.10e+1. In the year 2001, what is the difference between the Value added (current US$) of Andorra and Value added (current US$) of Saudi Arabia?
Offer a very short reply. -9.35e+1. In the year 2001, what is the difference between the Value added (current US$) of Brunei Darussalam and Value added (current US$) of Norway?
Your response must be concise. -5.79e+1. In the year 2001, what is the difference between the Value added (current US$) of Brunei Darussalam and Value added (current US$) of Saudi Arabia?
Provide a short and direct response. -9.04e+1. In the year 2001, what is the difference between the Value added (current US$) of Norway and Value added (current US$) of Saudi Arabia?
Your answer should be compact. -3.25e+1. In the year 2002, what is the difference between the Value added (current US$) in Andorra and Value added (current US$) in Brunei Darussalam?
Your response must be concise. -3.29e+09. In the year 2002, what is the difference between the Value added (current US$) in Andorra and Value added (current US$) in Norway?
Keep it short and to the point. -6.47e+1. In the year 2002, what is the difference between the Value added (current US$) in Andorra and Value added (current US$) in Saudi Arabia?
Provide a short and direct response. -9.68e+1. In the year 2002, what is the difference between the Value added (current US$) of Brunei Darussalam and Value added (current US$) of Norway?
Ensure brevity in your answer.  -6.14e+1. In the year 2002, what is the difference between the Value added (current US$) of Brunei Darussalam and Value added (current US$) of Saudi Arabia?
Provide a short and direct response. -9.35e+1. In the year 2002, what is the difference between the Value added (current US$) of Norway and Value added (current US$) of Saudi Arabia?
Your answer should be very brief. -3.21e+1. In the year 2003, what is the difference between the Value added (current US$) of Andorra and Value added (current US$) of Brunei Darussalam?
Your answer should be compact. -3.84e+09. In the year 2003, what is the difference between the Value added (current US$) of Andorra and Value added (current US$) of Norway?
Your answer should be compact. -7.61e+1. In the year 2003, what is the difference between the Value added (current US$) in Andorra and Value added (current US$) in Saudi Arabia?
Make the answer very short. -1.16e+11. In the year 2003, what is the difference between the Value added (current US$) of Brunei Darussalam and Value added (current US$) of Norway?
Your answer should be very brief. -7.22e+1. In the year 2003, what is the difference between the Value added (current US$) of Brunei Darussalam and Value added (current US$) of Saudi Arabia?
Give a very brief answer. -1.12e+11. In the year 2003, what is the difference between the Value added (current US$) of Norway and Value added (current US$) of Saudi Arabia?
Make the answer very short. -4.02e+1. In the year 2004, what is the difference between the Value added (current US$) of Andorra and Value added (current US$) of Brunei Darussalam?
Your response must be concise. -4.88e+09. In the year 2004, what is the difference between the Value added (current US$) in Andorra and Value added (current US$) in Norway?
Offer a very short reply. -9.21e+1. In the year 2004, what is the difference between the Value added (current US$) of Andorra and Value added (current US$) of Saudi Arabia?
Your answer should be very brief. -1.47e+11. In the year 2004, what is the difference between the Value added (current US$) in Brunei Darussalam and Value added (current US$) in Norway?
Offer a terse response. -8.72e+1. In the year 2004, what is the difference between the Value added (current US$) in Brunei Darussalam and Value added (current US$) in Saudi Arabia?
Your answer should be very brief. -1.43e+11. In the year 2004, what is the difference between the Value added (current US$) in Norway and Value added (current US$) in Saudi Arabia?
Provide a short and direct response. -5.54e+1. In the year 2005, what is the difference between the Value added (current US$) of Andorra and Value added (current US$) of Brunei Darussalam?
Give a very brief answer. -6.30e+09. In the year 2005, what is the difference between the Value added (current US$) in Andorra and Value added (current US$) in Norway?
Ensure brevity in your answer.  -1.17e+11. In the year 2005, what is the difference between the Value added (current US$) of Andorra and Value added (current US$) of Saudi Arabia?
Your answer should be compact. -2.03e+11. In the year 2005, what is the difference between the Value added (current US$) in Brunei Darussalam and Value added (current US$) in Norway?
Your answer should be compact. -1.10e+11. In the year 2005, what is the difference between the Value added (current US$) in Brunei Darussalam and Value added (current US$) in Saudi Arabia?
Your answer should be very brief. -1.97e+11. In the year 2005, what is the difference between the Value added (current US$) of Norway and Value added (current US$) of Saudi Arabia?
Your response must be concise. -8.67e+1. In the year 2006, what is the difference between the Value added (current US$) in Andorra and Value added (current US$) in Brunei Darussalam?
Offer a very short reply. -7.81e+09. In the year 2006, what is the difference between the Value added (current US$) of Andorra and Value added (current US$) of Norway?
Keep it short and to the point. -1.36e+11. In the year 2006, what is the difference between the Value added (current US$) in Andorra and Value added (current US$) in Saudi Arabia?
Your answer should be very brief. -2.36e+11. In the year 2006, what is the difference between the Value added (current US$) in Brunei Darussalam and Value added (current US$) in Norway?
Provide a succinct answer. -1.29e+11. In the year 2006, what is the difference between the Value added (current US$) of Brunei Darussalam and Value added (current US$) of Saudi Arabia?
Give a very brief answer. -2.29e+11. In the year 2006, what is the difference between the Value added (current US$) in Norway and Value added (current US$) in Saudi Arabia?
Your answer should be compact. -9.99e+1. In the year 2007, what is the difference between the Value added (current US$) in Andorra and Value added (current US$) in Brunei Darussalam?
Provide a succinct answer. -8.10e+09. In the year 2007, what is the difference between the Value added (current US$) in Andorra and Value added (current US$) in Norway?
Your response must be concise. -1.48e+11. In the year 2007, what is the difference between the Value added (current US$) of Andorra and Value added (current US$) of Saudi Arabia?
Make the answer very short. -2.62e+11. In the year 2007, what is the difference between the Value added (current US$) in Brunei Darussalam and Value added (current US$) in Norway?
Ensure brevity in your answer.  -1.40e+11. In the year 2007, what is the difference between the Value added (current US$) in Brunei Darussalam and Value added (current US$) in Saudi Arabia?
Give a very brief answer. -2.53e+11. In the year 2007, what is the difference between the Value added (current US$) of Norway and Value added (current US$) of Saudi Arabia?
Offer a very short reply. -1.13e+11. What is the ratio of the Value added (current US$) in Andorra in 2000 to that in 2001?
Make the answer very short. 0.93. What is the ratio of the Value added (current US$) of Brunei Darussalam in 2000 to that in 2001?
Your answer should be very brief. 1.14. What is the ratio of the Value added (current US$) of Norway in 2000 to that in 2001?
Give a very brief answer. 1.02. What is the ratio of the Value added (current US$) in Saudi Arabia in 2000 to that in 2001?
Provide a succinct answer. 1.08. What is the ratio of the Value added (current US$) of Andorra in 2000 to that in 2002?
Your answer should be compact. 0.78. What is the ratio of the Value added (current US$) in Brunei Darussalam in 2000 to that in 2002?
Provide a succinct answer. 1.08. What is the ratio of the Value added (current US$) of Norway in 2000 to that in 2002?
Ensure brevity in your answer.  0.96. What is the ratio of the Value added (current US$) of Saudi Arabia in 2000 to that in 2002?
Offer a very short reply. 1.05. What is the ratio of the Value added (current US$) of Andorra in 2000 to that in 2003?
Offer a very short reply. 0.54. What is the ratio of the Value added (current US$) of Brunei Darussalam in 2000 to that in 2003?
Your answer should be compact. 0.91. What is the ratio of the Value added (current US$) in Norway in 2000 to that in 2003?
Ensure brevity in your answer.  0.82. What is the ratio of the Value added (current US$) of Saudi Arabia in 2000 to that in 2003?
Your answer should be compact. 0.87. What is the ratio of the Value added (current US$) of Andorra in 2000 to that in 2004?
Your response must be concise. 0.43. What is the ratio of the Value added (current US$) in Brunei Darussalam in 2000 to that in 2004?
Your answer should be very brief. 0.72. What is the ratio of the Value added (current US$) of Norway in 2000 to that in 2004?
Ensure brevity in your answer.  0.68. What is the ratio of the Value added (current US$) in Saudi Arabia in 2000 to that in 2004?
Your response must be concise. 0.69. What is the ratio of the Value added (current US$) in Andorra in 2000 to that in 2005?
Provide a succinct answer. 0.38. What is the ratio of the Value added (current US$) in Brunei Darussalam in 2000 to that in 2005?
Make the answer very short. 0.56. What is the ratio of the Value added (current US$) of Norway in 2000 to that in 2005?
Keep it short and to the point. 0.53. What is the ratio of the Value added (current US$) in Saudi Arabia in 2000 to that in 2005?
Your answer should be very brief. 0.5. What is the ratio of the Value added (current US$) of Andorra in 2000 to that in 2006?
Make the answer very short. 0.34. What is the ratio of the Value added (current US$) of Brunei Darussalam in 2000 to that in 2006?
Provide a short and direct response. 0.46. What is the ratio of the Value added (current US$) in Norway in 2000 to that in 2006?
Your answer should be compact. 0.46. What is the ratio of the Value added (current US$) in Saudi Arabia in 2000 to that in 2006?
Your response must be concise. 0.43. What is the ratio of the Value added (current US$) of Andorra in 2000 to that in 2007?
Keep it short and to the point. 0.31. What is the ratio of the Value added (current US$) in Brunei Darussalam in 2000 to that in 2007?
Keep it short and to the point. 0.44. What is the ratio of the Value added (current US$) in Norway in 2000 to that in 2007?
Offer a terse response. 0.42. What is the ratio of the Value added (current US$) of Saudi Arabia in 2000 to that in 2007?
Ensure brevity in your answer.  0.39. What is the ratio of the Value added (current US$) of Andorra in 2001 to that in 2002?
Keep it short and to the point. 0.84. What is the ratio of the Value added (current US$) of Brunei Darussalam in 2001 to that in 2002?
Provide a succinct answer. 0.95. What is the ratio of the Value added (current US$) in Norway in 2001 to that in 2002?
Provide a succinct answer. 0.94. What is the ratio of the Value added (current US$) in Saudi Arabia in 2001 to that in 2002?
Ensure brevity in your answer.  0.97. What is the ratio of the Value added (current US$) in Andorra in 2001 to that in 2003?
Your answer should be very brief. 0.59. What is the ratio of the Value added (current US$) in Brunei Darussalam in 2001 to that in 2003?
Provide a short and direct response. 0.8. What is the ratio of the Value added (current US$) of Norway in 2001 to that in 2003?
Offer a terse response. 0.8. What is the ratio of the Value added (current US$) in Saudi Arabia in 2001 to that in 2003?
Your answer should be very brief. 0.8. What is the ratio of the Value added (current US$) in Andorra in 2001 to that in 2004?
Ensure brevity in your answer.  0.47. What is the ratio of the Value added (current US$) of Brunei Darussalam in 2001 to that in 2004?
Keep it short and to the point. 0.63. What is the ratio of the Value added (current US$) in Norway in 2001 to that in 2004?
Provide a short and direct response. 0.66. What is the ratio of the Value added (current US$) in Saudi Arabia in 2001 to that in 2004?
Your answer should be very brief. 0.63. What is the ratio of the Value added (current US$) of Andorra in 2001 to that in 2005?
Offer a very short reply. 0.41. What is the ratio of the Value added (current US$) of Brunei Darussalam in 2001 to that in 2005?
Offer a terse response. 0.49. What is the ratio of the Value added (current US$) of Norway in 2001 to that in 2005?
Offer a terse response. 0.52. What is the ratio of the Value added (current US$) in Saudi Arabia in 2001 to that in 2005?
Ensure brevity in your answer.  0.46. What is the ratio of the Value added (current US$) in Andorra in 2001 to that in 2006?
Give a very brief answer. 0.37. What is the ratio of the Value added (current US$) of Brunei Darussalam in 2001 to that in 2006?
Offer a terse response. 0.4. What is the ratio of the Value added (current US$) in Norway in 2001 to that in 2006?
Offer a very short reply. 0.45. What is the ratio of the Value added (current US$) of Saudi Arabia in 2001 to that in 2006?
Provide a succinct answer. 0.4. What is the ratio of the Value added (current US$) in Andorra in 2001 to that in 2007?
Offer a terse response. 0.34. What is the ratio of the Value added (current US$) in Brunei Darussalam in 2001 to that in 2007?
Offer a very short reply. 0.39. What is the ratio of the Value added (current US$) in Norway in 2001 to that in 2007?
Keep it short and to the point. 0.41. What is the ratio of the Value added (current US$) in Saudi Arabia in 2001 to that in 2007?
Your answer should be compact. 0.36. What is the ratio of the Value added (current US$) in Andorra in 2002 to that in 2003?
Your answer should be very brief. 0.7. What is the ratio of the Value added (current US$) of Brunei Darussalam in 2002 to that in 2003?
Offer a terse response. 0.84. What is the ratio of the Value added (current US$) of Norway in 2002 to that in 2003?
Your response must be concise. 0.85. What is the ratio of the Value added (current US$) of Saudi Arabia in 2002 to that in 2003?
Ensure brevity in your answer.  0.83. What is the ratio of the Value added (current US$) of Andorra in 2002 to that in 2004?
Your answer should be compact. 0.56. What is the ratio of the Value added (current US$) of Brunei Darussalam in 2002 to that in 2004?
Your answer should be compact. 0.66. What is the ratio of the Value added (current US$) of Norway in 2002 to that in 2004?
Give a very brief answer. 0.7. What is the ratio of the Value added (current US$) of Saudi Arabia in 2002 to that in 2004?
Provide a succinct answer. 0.66. What is the ratio of the Value added (current US$) in Andorra in 2002 to that in 2005?
Provide a succinct answer. 0.49. What is the ratio of the Value added (current US$) of Brunei Darussalam in 2002 to that in 2005?
Provide a short and direct response. 0.52. What is the ratio of the Value added (current US$) in Norway in 2002 to that in 2005?
Keep it short and to the point. 0.55. What is the ratio of the Value added (current US$) of Saudi Arabia in 2002 to that in 2005?
Give a very brief answer. 0.48. What is the ratio of the Value added (current US$) in Andorra in 2002 to that in 2006?
Offer a very short reply. 0.44. What is the ratio of the Value added (current US$) of Brunei Darussalam in 2002 to that in 2006?
Provide a short and direct response. 0.42. What is the ratio of the Value added (current US$) in Norway in 2002 to that in 2006?
Make the answer very short. 0.47. What is the ratio of the Value added (current US$) in Saudi Arabia in 2002 to that in 2006?
Give a very brief answer. 0.41. What is the ratio of the Value added (current US$) in Andorra in 2002 to that in 2007?
Your response must be concise. 0.4. What is the ratio of the Value added (current US$) of Brunei Darussalam in 2002 to that in 2007?
Offer a very short reply. 0.41. What is the ratio of the Value added (current US$) in Norway in 2002 to that in 2007?
Provide a succinct answer. 0.44. What is the ratio of the Value added (current US$) of Saudi Arabia in 2002 to that in 2007?
Offer a very short reply. 0.37. What is the ratio of the Value added (current US$) of Andorra in 2003 to that in 2004?
Provide a short and direct response. 0.8. What is the ratio of the Value added (current US$) in Brunei Darussalam in 2003 to that in 2004?
Ensure brevity in your answer.  0.79. What is the ratio of the Value added (current US$) of Norway in 2003 to that in 2004?
Your answer should be compact. 0.83. What is the ratio of the Value added (current US$) of Saudi Arabia in 2003 to that in 2004?
Offer a terse response. 0.79. What is the ratio of the Value added (current US$) of Andorra in 2003 to that in 2005?
Offer a terse response. 0.7. What is the ratio of the Value added (current US$) in Brunei Darussalam in 2003 to that in 2005?
Provide a short and direct response. 0.62. What is the ratio of the Value added (current US$) in Norway in 2003 to that in 2005?
Your answer should be compact. 0.65. What is the ratio of the Value added (current US$) of Saudi Arabia in 2003 to that in 2005?
Your response must be concise. 0.57. What is the ratio of the Value added (current US$) of Andorra in 2003 to that in 2006?
Keep it short and to the point. 0.63. What is the ratio of the Value added (current US$) in Brunei Darussalam in 2003 to that in 2006?
Keep it short and to the point. 0.5. What is the ratio of the Value added (current US$) in Norway in 2003 to that in 2006?
Provide a short and direct response. 0.56. What is the ratio of the Value added (current US$) in Saudi Arabia in 2003 to that in 2006?
Your answer should be compact. 0.49. What is the ratio of the Value added (current US$) of Andorra in 2003 to that in 2007?
Offer a very short reply. 0.58. What is the ratio of the Value added (current US$) in Brunei Darussalam in 2003 to that in 2007?
Your answer should be compact. 0.48. What is the ratio of the Value added (current US$) of Norway in 2003 to that in 2007?
Your response must be concise. 0.51. What is the ratio of the Value added (current US$) of Saudi Arabia in 2003 to that in 2007?
Give a very brief answer. 0.44. What is the ratio of the Value added (current US$) in Andorra in 2004 to that in 2005?
Give a very brief answer. 0.88. What is the ratio of the Value added (current US$) in Brunei Darussalam in 2004 to that in 2005?
Give a very brief answer. 0.78. What is the ratio of the Value added (current US$) in Norway in 2004 to that in 2005?
Provide a short and direct response. 0.79. What is the ratio of the Value added (current US$) in Saudi Arabia in 2004 to that in 2005?
Your answer should be compact. 0.73. What is the ratio of the Value added (current US$) of Andorra in 2004 to that in 2006?
Keep it short and to the point. 0.79. What is the ratio of the Value added (current US$) in Brunei Darussalam in 2004 to that in 2006?
Provide a short and direct response. 0.64. What is the ratio of the Value added (current US$) of Norway in 2004 to that in 2006?
Offer a terse response. 0.68. What is the ratio of the Value added (current US$) in Saudi Arabia in 2004 to that in 2006?
Make the answer very short. 0.62. What is the ratio of the Value added (current US$) of Andorra in 2004 to that in 2007?
Make the answer very short. 0.73. What is the ratio of the Value added (current US$) in Brunei Darussalam in 2004 to that in 2007?
Ensure brevity in your answer.  0.61. What is the ratio of the Value added (current US$) of Norway in 2004 to that in 2007?
Keep it short and to the point. 0.62. What is the ratio of the Value added (current US$) of Saudi Arabia in 2004 to that in 2007?
Your answer should be compact. 0.56. What is the ratio of the Value added (current US$) of Andorra in 2005 to that in 2006?
Offer a terse response. 0.9. What is the ratio of the Value added (current US$) of Brunei Darussalam in 2005 to that in 2006?
Provide a short and direct response. 0.81. What is the ratio of the Value added (current US$) of Norway in 2005 to that in 2006?
Offer a very short reply. 0.86. What is the ratio of the Value added (current US$) of Saudi Arabia in 2005 to that in 2006?
Offer a terse response. 0.86. What is the ratio of the Value added (current US$) of Andorra in 2005 to that in 2007?
Offer a terse response. 0.82. What is the ratio of the Value added (current US$) in Brunei Darussalam in 2005 to that in 2007?
Your response must be concise. 0.78. What is the ratio of the Value added (current US$) in Norway in 2005 to that in 2007?
Your response must be concise. 0.79. What is the ratio of the Value added (current US$) in Saudi Arabia in 2005 to that in 2007?
Your answer should be very brief. 0.78. What is the ratio of the Value added (current US$) of Andorra in 2006 to that in 2007?
Provide a short and direct response. 0.91. What is the ratio of the Value added (current US$) of Brunei Darussalam in 2006 to that in 2007?
Provide a short and direct response. 0.96. What is the ratio of the Value added (current US$) in Norway in 2006 to that in 2007?
Give a very brief answer. 0.92. What is the ratio of the Value added (current US$) of Saudi Arabia in 2006 to that in 2007?
Give a very brief answer. 0.9. What is the difference between the highest and the second highest Value added (current US$) of Andorra?
Keep it short and to the point. 5.46e+07. What is the difference between the highest and the second highest Value added (current US$) in Brunei Darussalam?
Your answer should be very brief. 3.39e+08. What is the difference between the highest and the second highest Value added (current US$) in Norway?
Keep it short and to the point. 1.20e+1. What is the difference between the highest and the second highest Value added (current US$) in Saudi Arabia?
Provide a succinct answer. 2.52e+1. What is the difference between the highest and the lowest Value added (current US$) of Andorra?
Provide a short and direct response. 4.37e+08. What is the difference between the highest and the lowest Value added (current US$) in Brunei Darussalam?
Give a very brief answer. 5.37e+09. What is the difference between the highest and the lowest Value added (current US$) in Norway?
Your response must be concise. 8.78e+1. What is the difference between the highest and the lowest Value added (current US$) in Saudi Arabia?
Ensure brevity in your answer.  1.68e+11. 